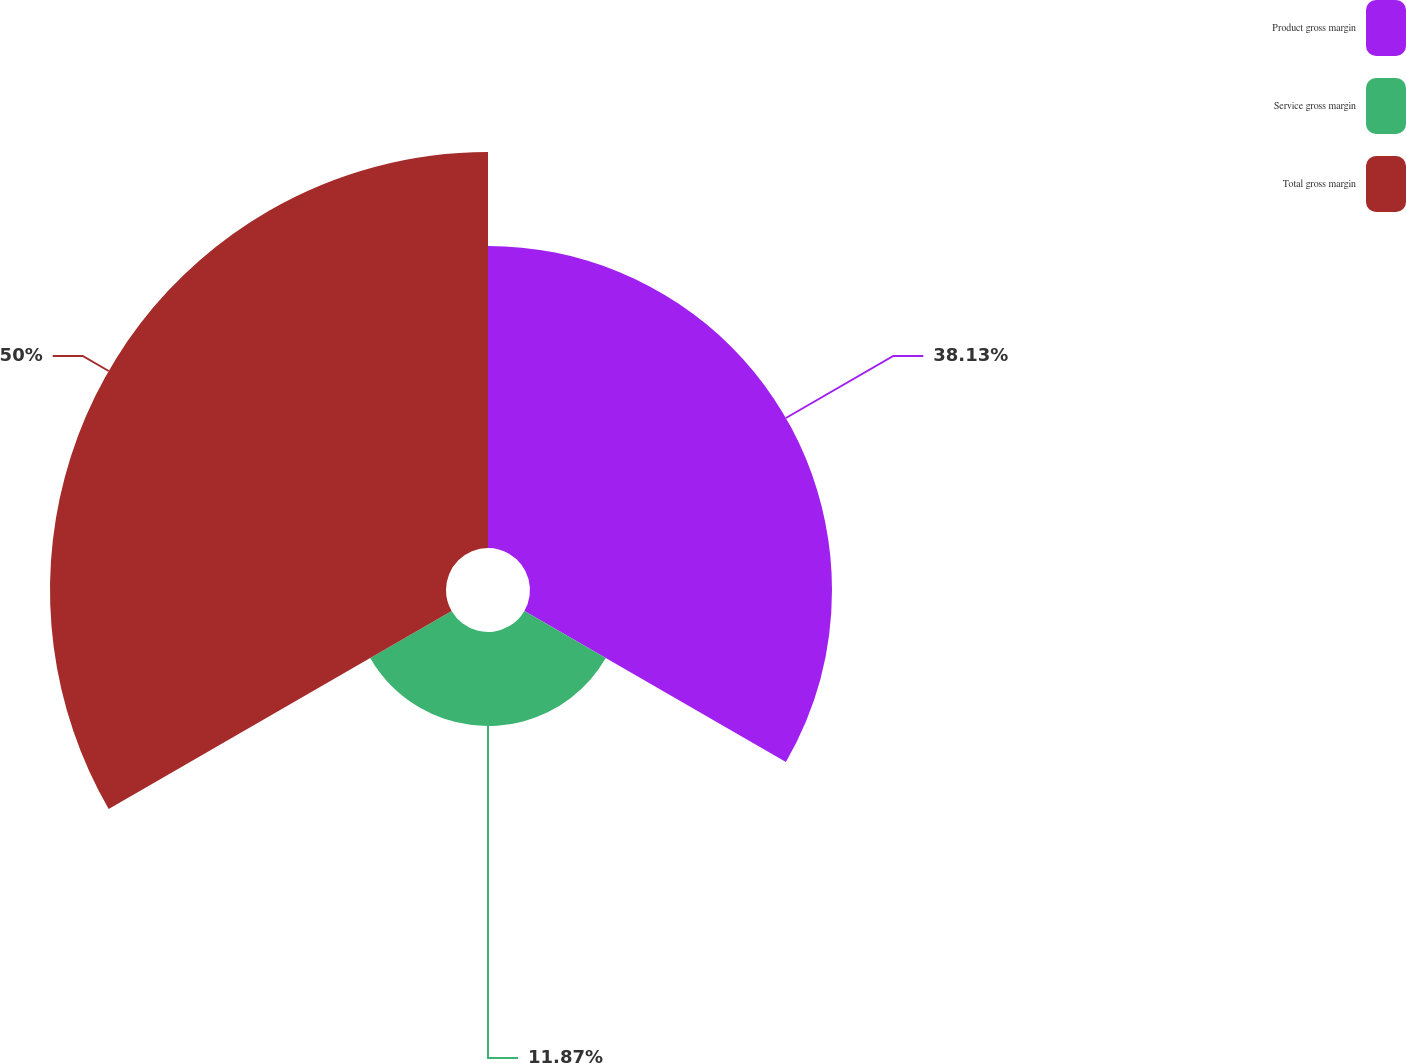<chart> <loc_0><loc_0><loc_500><loc_500><pie_chart><fcel>Product gross margin<fcel>Service gross margin<fcel>Total gross margin<nl><fcel>38.13%<fcel>11.87%<fcel>50.0%<nl></chart> 